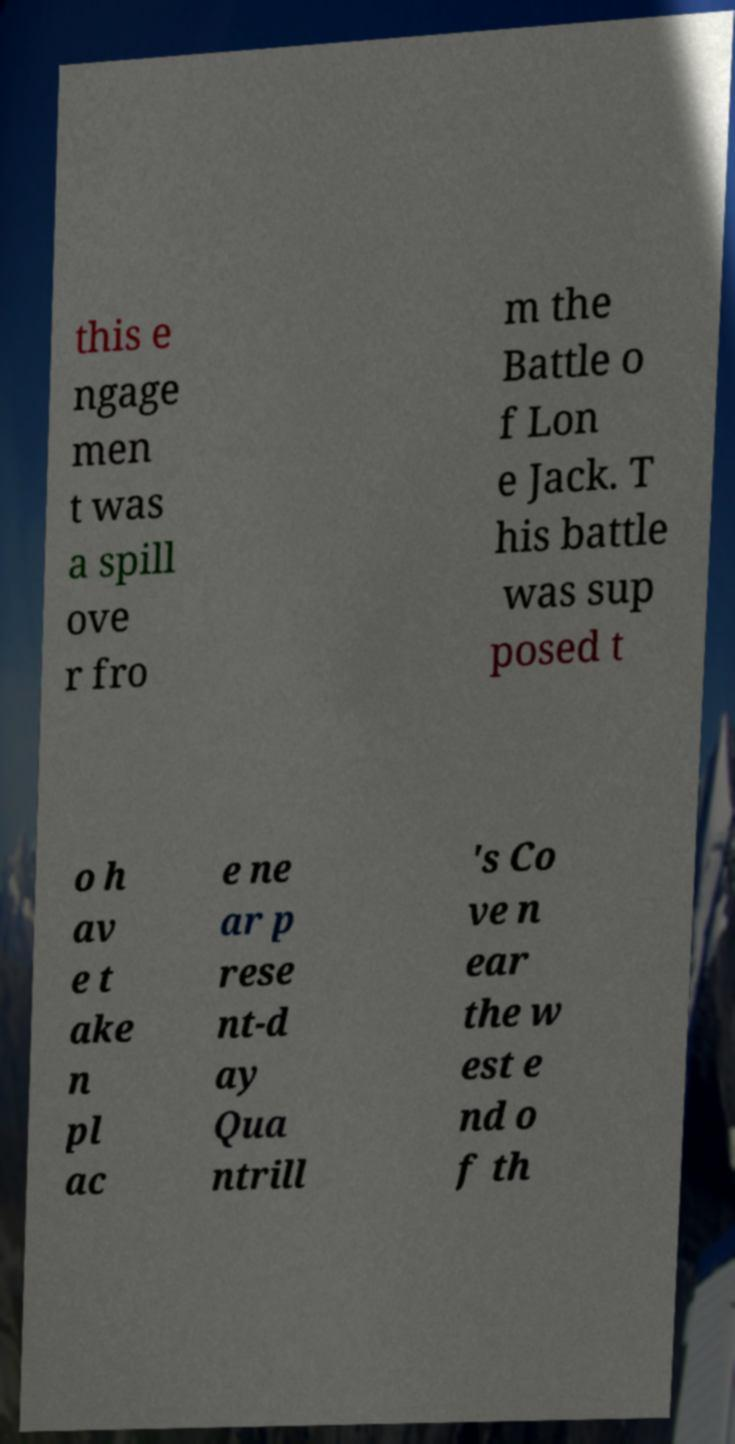Could you assist in decoding the text presented in this image and type it out clearly? this e ngage men t was a spill ove r fro m the Battle o f Lon e Jack. T his battle was sup posed t o h av e t ake n pl ac e ne ar p rese nt-d ay Qua ntrill 's Co ve n ear the w est e nd o f th 